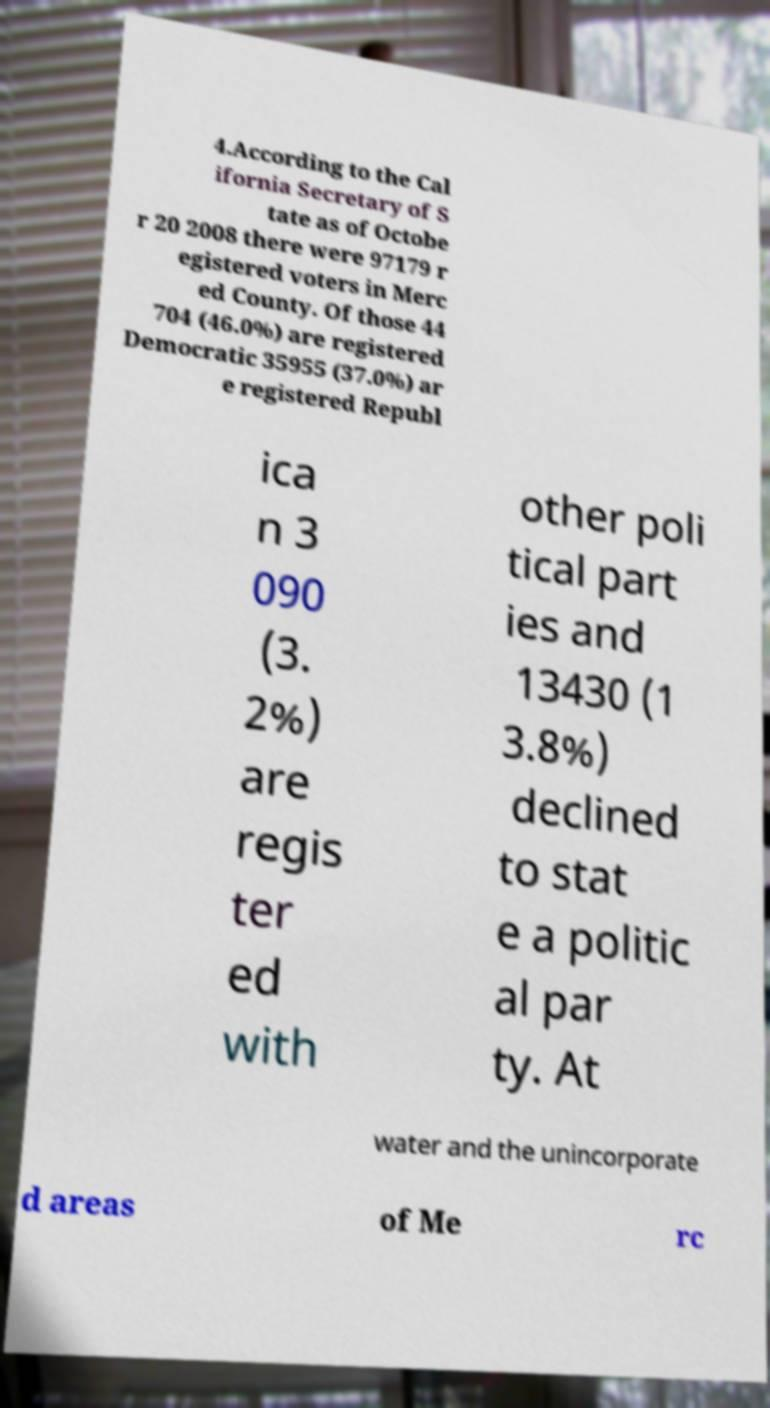Can you accurately transcribe the text from the provided image for me? 4.According to the Cal ifornia Secretary of S tate as of Octobe r 20 2008 there were 97179 r egistered voters in Merc ed County. Of those 44 704 (46.0%) are registered Democratic 35955 (37.0%) ar e registered Republ ica n 3 090 (3. 2%) are regis ter ed with other poli tical part ies and 13430 (1 3.8%) declined to stat e a politic al par ty. At water and the unincorporate d areas of Me rc 